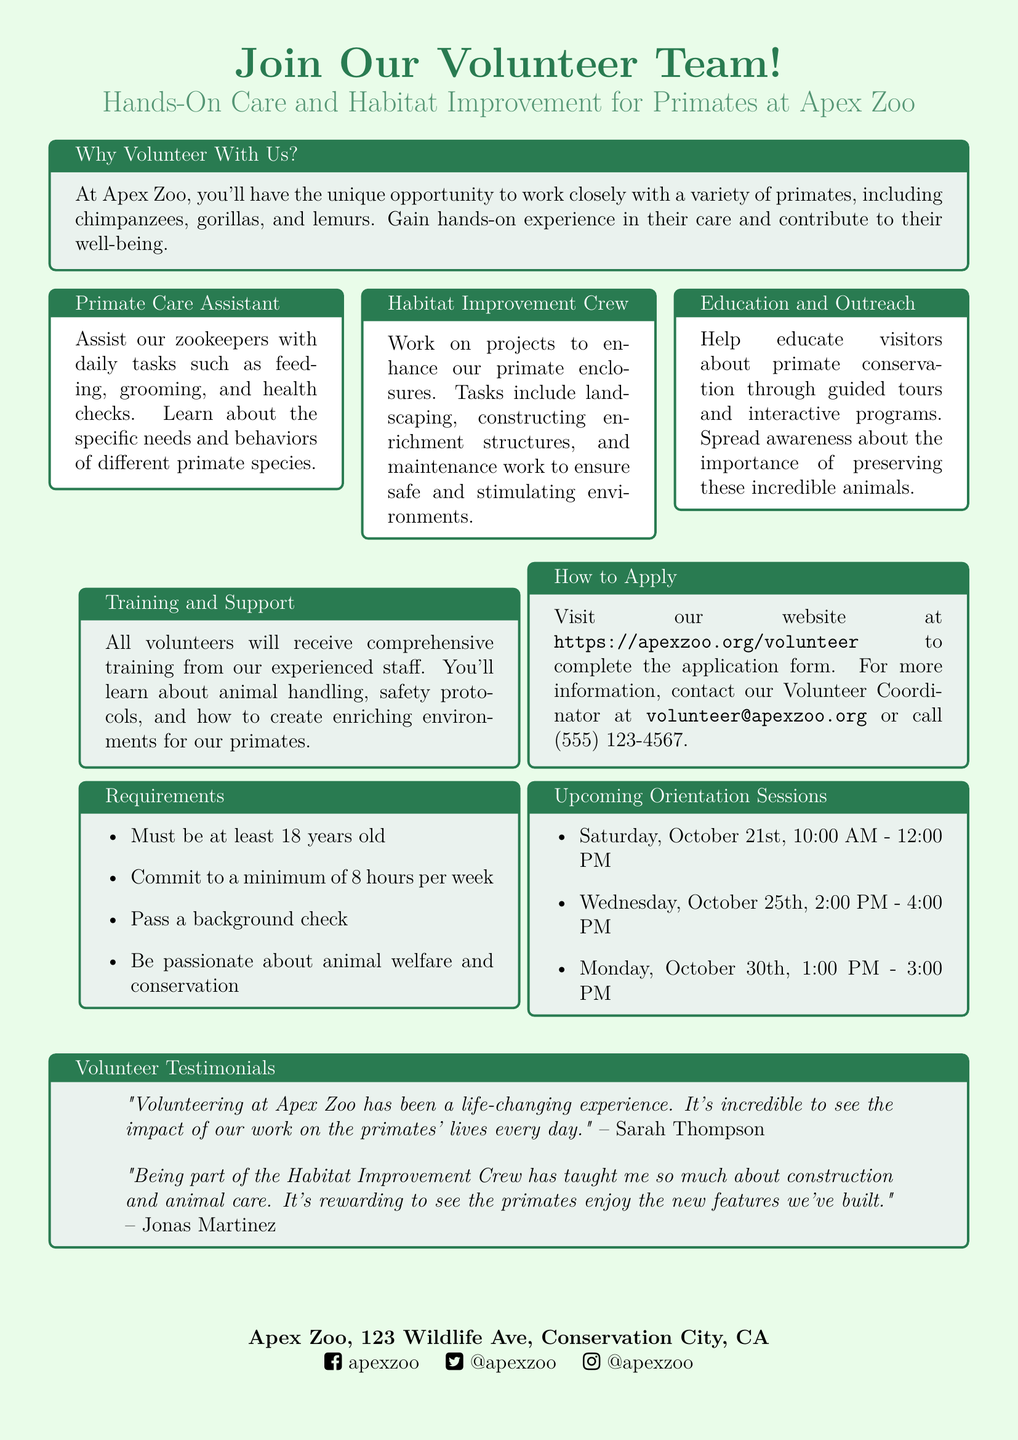What is the title of the advertisement? The title of the advertisement is prominently displayed at the top.
Answer: Join Our Volunteer Team! What are the responsibilities of a Primate Care Assistant? This role includes assisting zookeepers with specific tasks related to primates.
Answer: Feeding, grooming, and health checks How many hours per week must volunteers commit? The requirements section lists the minimum commitment in hours per week.
Answer: 8 hours What is the minimum age requirement to volunteer? The requirements specify the age limit for volunteers.
Answer: 18 years old When is the first upcoming orientation session? The dates for upcoming orientation sessions are listed in the document.
Answer: Saturday, October 21st, 10:00 AM - 12:00 PM What is the contact email for the Volunteer Coordinator? The contact information section provides an email for inquiries.
Answer: volunteer@apexzoo.org What type of experience can volunteers gain? The overview section describes the overall experience volunteers can expect.
Answer: Hands-on experience in their care What will all volunteers receive before starting their duties? The training section outlines what volunteers will receive to prepare them.
Answer: Comprehensive training Who can provide testimonials about their experiences? The testimonials section includes quotes from individuals who have volunteered.
Answer: Sarah Thompson and Jonas Martinez 